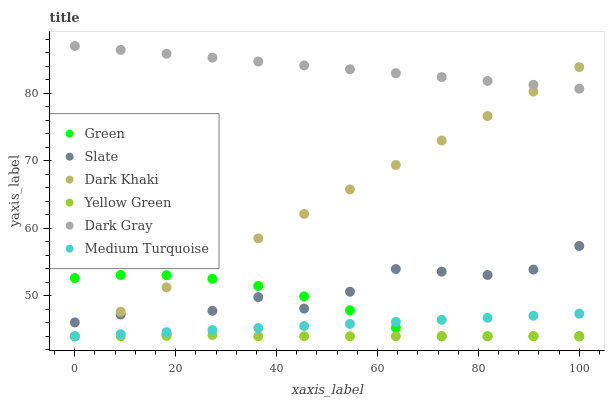Does Yellow Green have the minimum area under the curve?
Answer yes or no. Yes. Does Dark Gray have the maximum area under the curve?
Answer yes or no. Yes. Does Slate have the minimum area under the curve?
Answer yes or no. No. Does Slate have the maximum area under the curve?
Answer yes or no. No. Is Dark Khaki the smoothest?
Answer yes or no. Yes. Is Slate the roughest?
Answer yes or no. Yes. Is Yellow Green the smoothest?
Answer yes or no. No. Is Yellow Green the roughest?
Answer yes or no. No. Does Yellow Green have the lowest value?
Answer yes or no. Yes. Does Slate have the lowest value?
Answer yes or no. No. Does Dark Gray have the highest value?
Answer yes or no. Yes. Does Slate have the highest value?
Answer yes or no. No. Is Yellow Green less than Dark Gray?
Answer yes or no. Yes. Is Slate greater than Yellow Green?
Answer yes or no. Yes. Does Green intersect Dark Khaki?
Answer yes or no. Yes. Is Green less than Dark Khaki?
Answer yes or no. No. Is Green greater than Dark Khaki?
Answer yes or no. No. Does Yellow Green intersect Dark Gray?
Answer yes or no. No. 